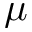Convert formula to latex. <formula><loc_0><loc_0><loc_500><loc_500>\mu</formula> 